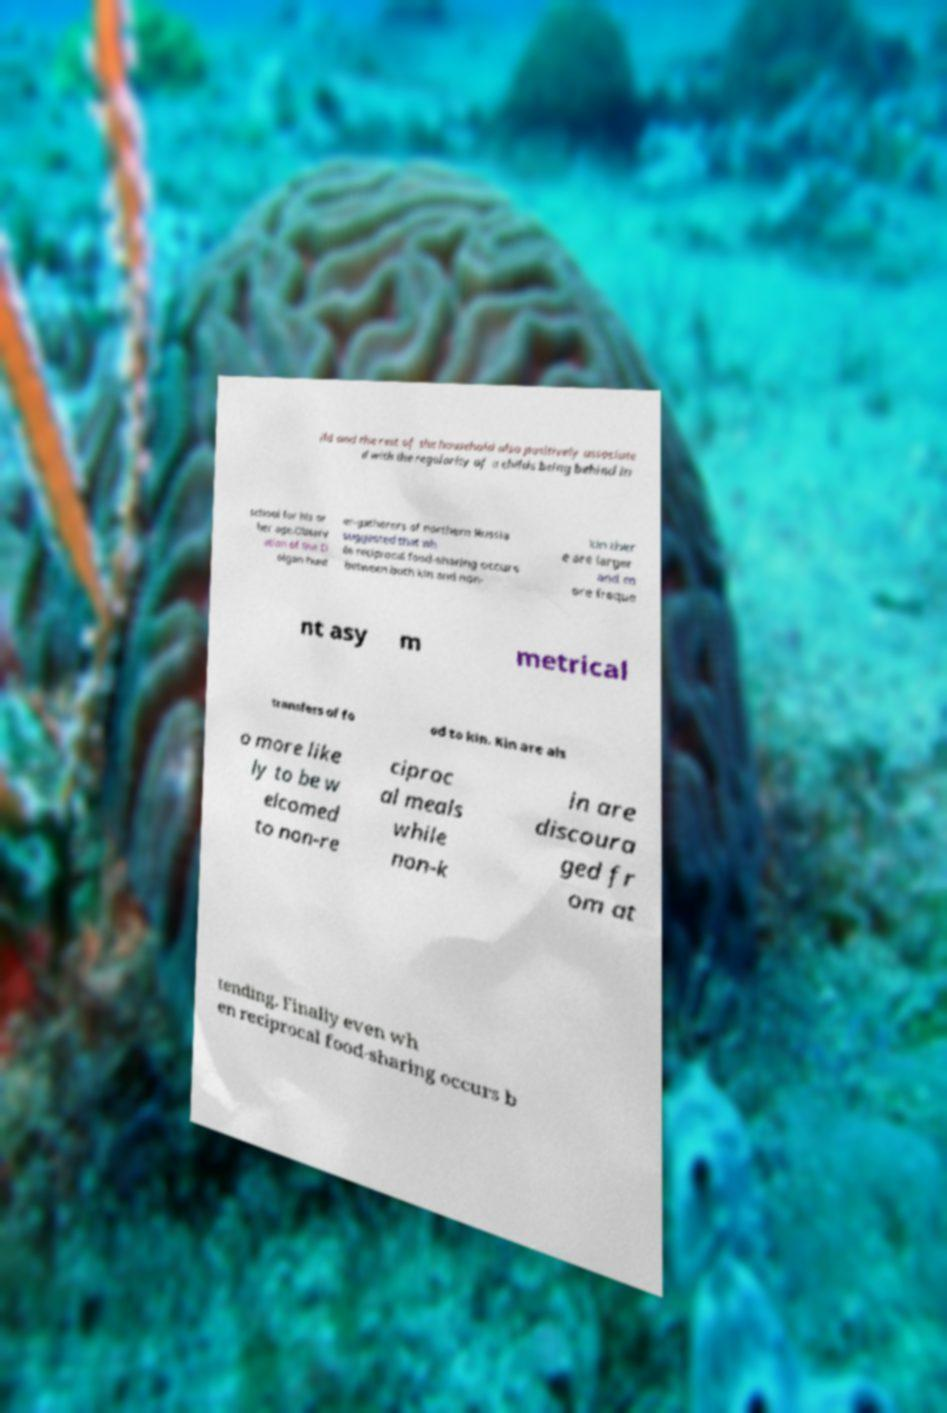Please read and relay the text visible in this image. What does it say? ild and the rest of the household also positively associate d with the regularity of a childs being behind in school for his or her age.Observ ation of the D olgan hunt er-gatherers of northern Russia suggested that wh ile reciprocal food-sharing occurs between both kin and non- kin ther e are larger and m ore freque nt asy m metrical transfers of fo od to kin. Kin are als o more like ly to be w elcomed to non-re ciproc al meals while non-k in are discoura ged fr om at tending. Finally even wh en reciprocal food-sharing occurs b 